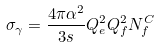<formula> <loc_0><loc_0><loc_500><loc_500>\sigma _ { \gamma } = \frac { 4 \pi \alpha ^ { 2 } } { 3 s } Q _ { e } ^ { 2 } Q _ { f } ^ { 2 } N _ { f } ^ { C }</formula> 